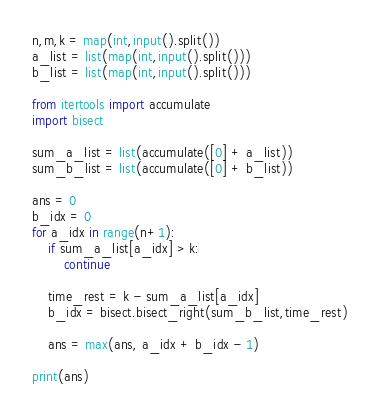<code> <loc_0><loc_0><loc_500><loc_500><_Python_>n,m,k = map(int,input().split())
a_list = list(map(int,input().split()))
b_list = list(map(int,input().split()))

from itertools import accumulate
import bisect

sum_a_list = list(accumulate([0] + a_list))
sum_b_list = list(accumulate([0] + b_list))

ans = 0
b_idx = 0
for a_idx in range(n+1):
    if sum_a_list[a_idx] > k:
        continue

    time_rest = k - sum_a_list[a_idx]
    b_idx = bisect.bisect_right(sum_b_list,time_rest)

    ans = max(ans, a_idx + b_idx - 1)

print(ans)</code> 